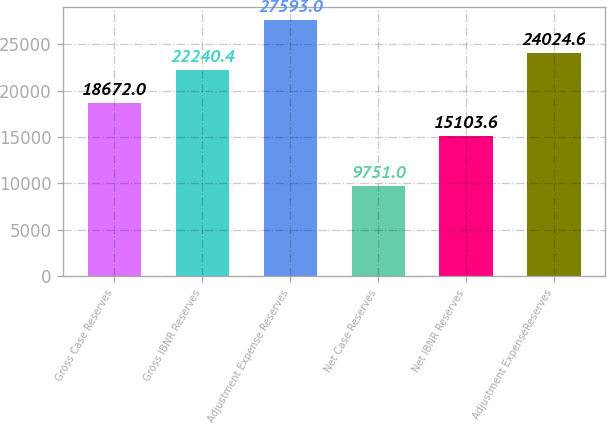Convert chart to OTSL. <chart><loc_0><loc_0><loc_500><loc_500><bar_chart><fcel>Gross Case Reserves<fcel>Gross IBNR Reserves<fcel>Adjustment Expense Reserves<fcel>Net Case Reserves<fcel>Net IBNR Reserves<fcel>Adjustment ExpenseReserves<nl><fcel>18672<fcel>22240.4<fcel>27593<fcel>9751<fcel>15103.6<fcel>24024.6<nl></chart> 